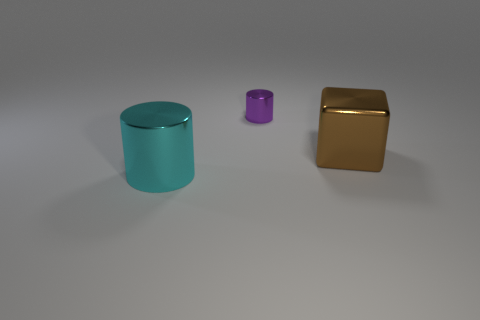There is a small cylinder that is made of the same material as the cyan object; what is its color?
Provide a succinct answer. Purple. What is the color of the other object that is the same shape as the small purple thing?
Offer a terse response. Cyan. The cyan thing is what size?
Give a very brief answer. Large. What size is the other object that is the same shape as the cyan shiny object?
Your answer should be compact. Small. There is a metallic cube; how many cyan metallic cylinders are right of it?
Keep it short and to the point. 0. What is the color of the cylinder behind the object that is on the left side of the tiny purple metal cylinder?
Your response must be concise. Purple. Are there any other things that have the same shape as the purple object?
Your answer should be compact. Yes. Is the number of brown metallic cubes to the right of the big metallic block the same as the number of tiny metallic things that are right of the small metal cylinder?
Your answer should be very brief. Yes. What number of balls are brown objects or cyan objects?
Provide a short and direct response. 0. What is the shape of the thing on the left side of the small metallic object?
Make the answer very short. Cylinder. 